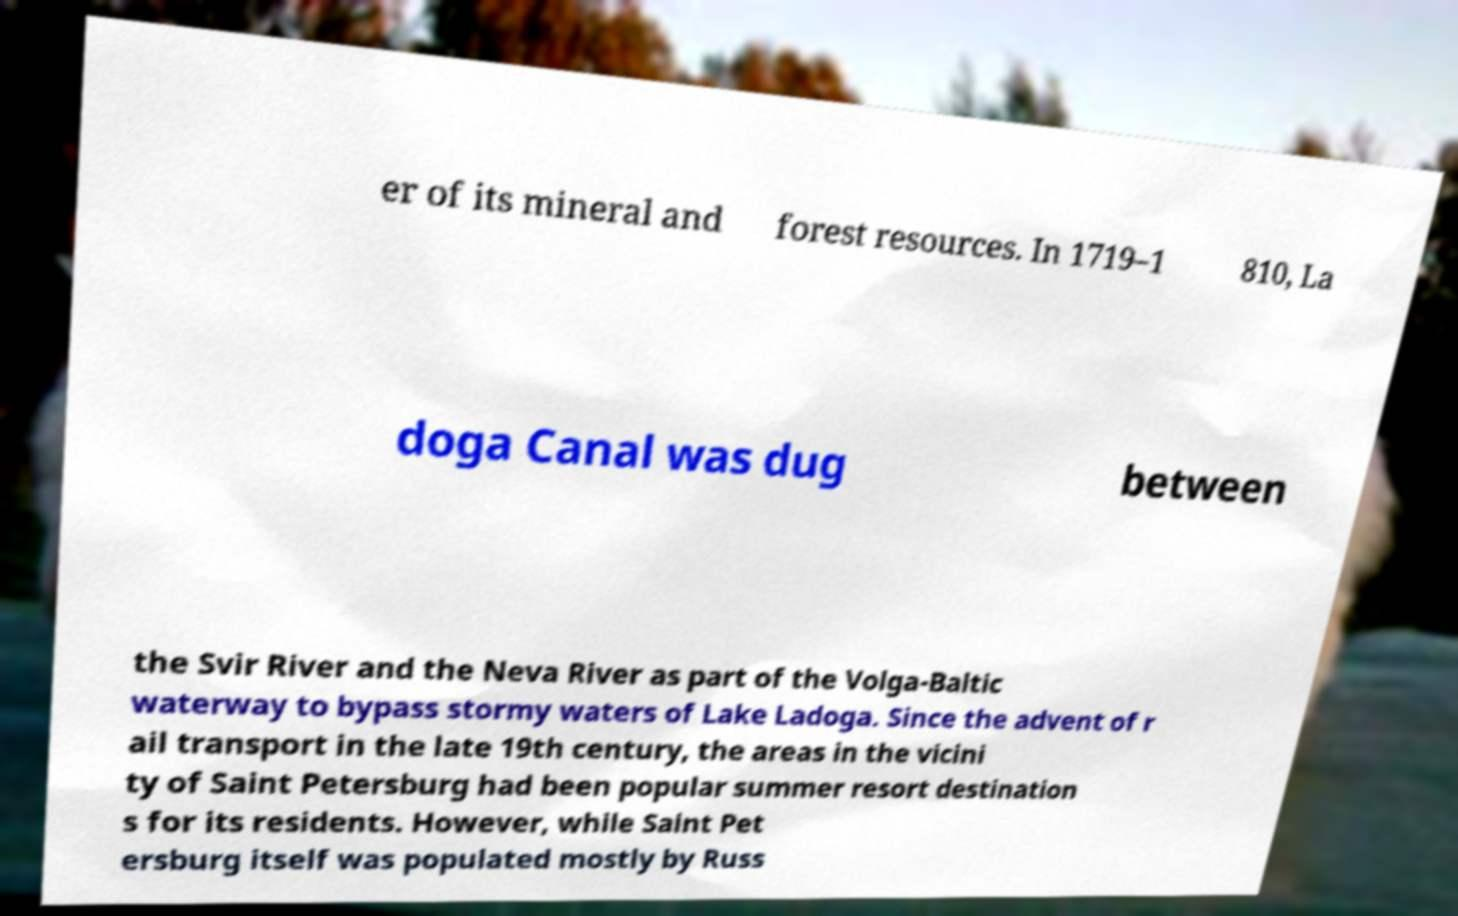Could you assist in decoding the text presented in this image and type it out clearly? er of its mineral and forest resources. In 1719–1 810, La doga Canal was dug between the Svir River and the Neva River as part of the Volga-Baltic waterway to bypass stormy waters of Lake Ladoga. Since the advent of r ail transport in the late 19th century, the areas in the vicini ty of Saint Petersburg had been popular summer resort destination s for its residents. However, while Saint Pet ersburg itself was populated mostly by Russ 